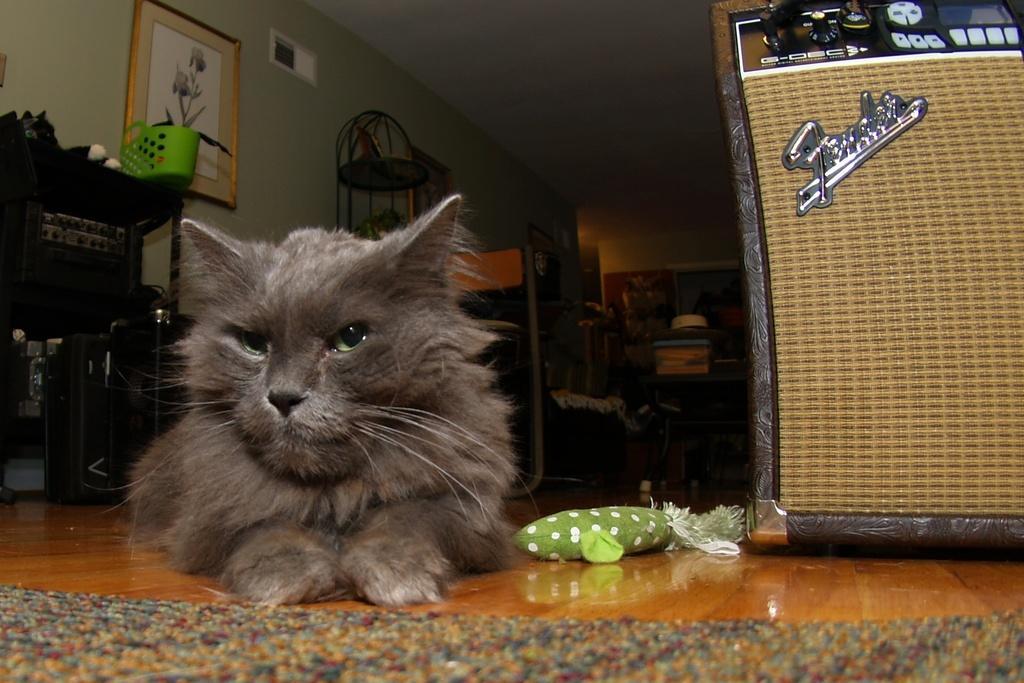Please provide a concise description of this image. Here I can see a cat on the floor. Beside that there is a toy. On the right side I can see an object. In the background there are some tables, a rack are arranged. On the top I can see few frames are attached to the wall. At the bottom of the image I can see a mat on the floor. 